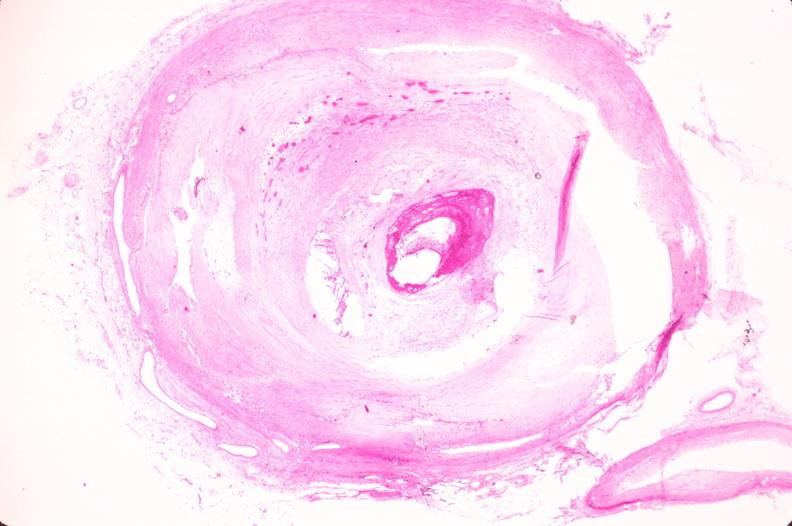does artery show coronary artery atherosclerosis?
Answer the question using a single word or phrase. No 